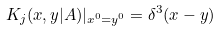Convert formula to latex. <formula><loc_0><loc_0><loc_500><loc_500>K _ { j } ( x , y | A ) | _ { x ^ { 0 } = y ^ { 0 } } = \delta ^ { 3 } ( { x } - { y } )</formula> 